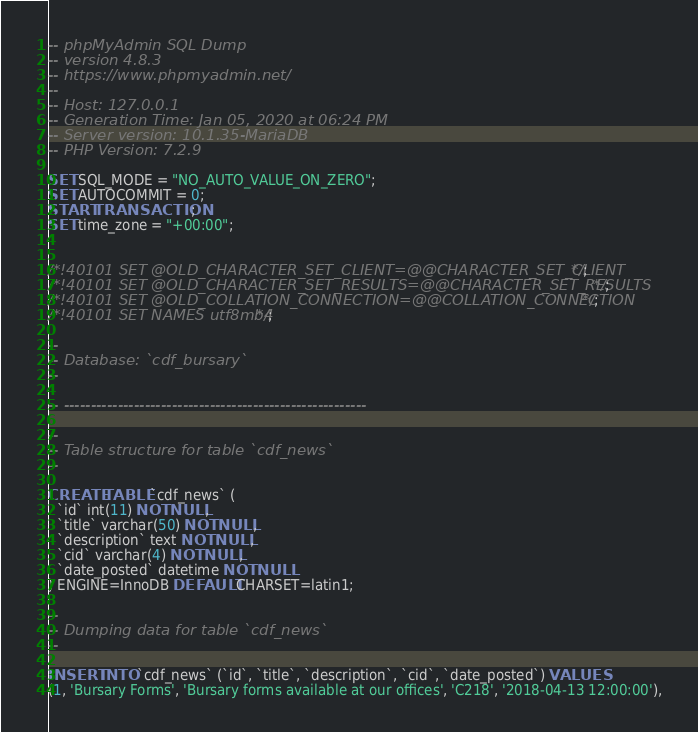<code> <loc_0><loc_0><loc_500><loc_500><_SQL_>-- phpMyAdmin SQL Dump
-- version 4.8.3
-- https://www.phpmyadmin.net/
--
-- Host: 127.0.0.1
-- Generation Time: Jan 05, 2020 at 06:24 PM
-- Server version: 10.1.35-MariaDB
-- PHP Version: 7.2.9

SET SQL_MODE = "NO_AUTO_VALUE_ON_ZERO";
SET AUTOCOMMIT = 0;
START TRANSACTION;
SET time_zone = "+00:00";


/*!40101 SET @OLD_CHARACTER_SET_CLIENT=@@CHARACTER_SET_CLIENT */;
/*!40101 SET @OLD_CHARACTER_SET_RESULTS=@@CHARACTER_SET_RESULTS */;
/*!40101 SET @OLD_COLLATION_CONNECTION=@@COLLATION_CONNECTION */;
/*!40101 SET NAMES utf8mb4 */;

--
-- Database: `cdf_bursary`
--

-- --------------------------------------------------------

--
-- Table structure for table `cdf_news`
--

CREATE TABLE `cdf_news` (
  `id` int(11) NOT NULL,
  `title` varchar(50) NOT NULL,
  `description` text NOT NULL,
  `cid` varchar(4) NOT NULL,
  `date_posted` datetime NOT NULL
) ENGINE=InnoDB DEFAULT CHARSET=latin1;

--
-- Dumping data for table `cdf_news`
--

INSERT INTO `cdf_news` (`id`, `title`, `description`, `cid`, `date_posted`) VALUES
(1, 'Bursary Forms', 'Bursary forms available at our offices', 'C218', '2018-04-13 12:00:00'),</code> 